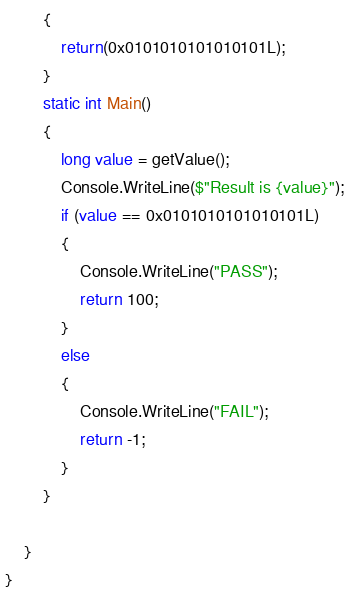<code> <loc_0><loc_0><loc_500><loc_500><_C#_>        {
            return(0x0101010101010101L);
        }
        static int Main()
        {
            long value = getValue();
            Console.WriteLine($"Result is {value}");
            if (value == 0x0101010101010101L)
            {
                Console.WriteLine("PASS");
                return 100;
            }
            else
            {
                Console.WriteLine("FAIL");
                return -1;
            }
        }

    }
}
</code> 